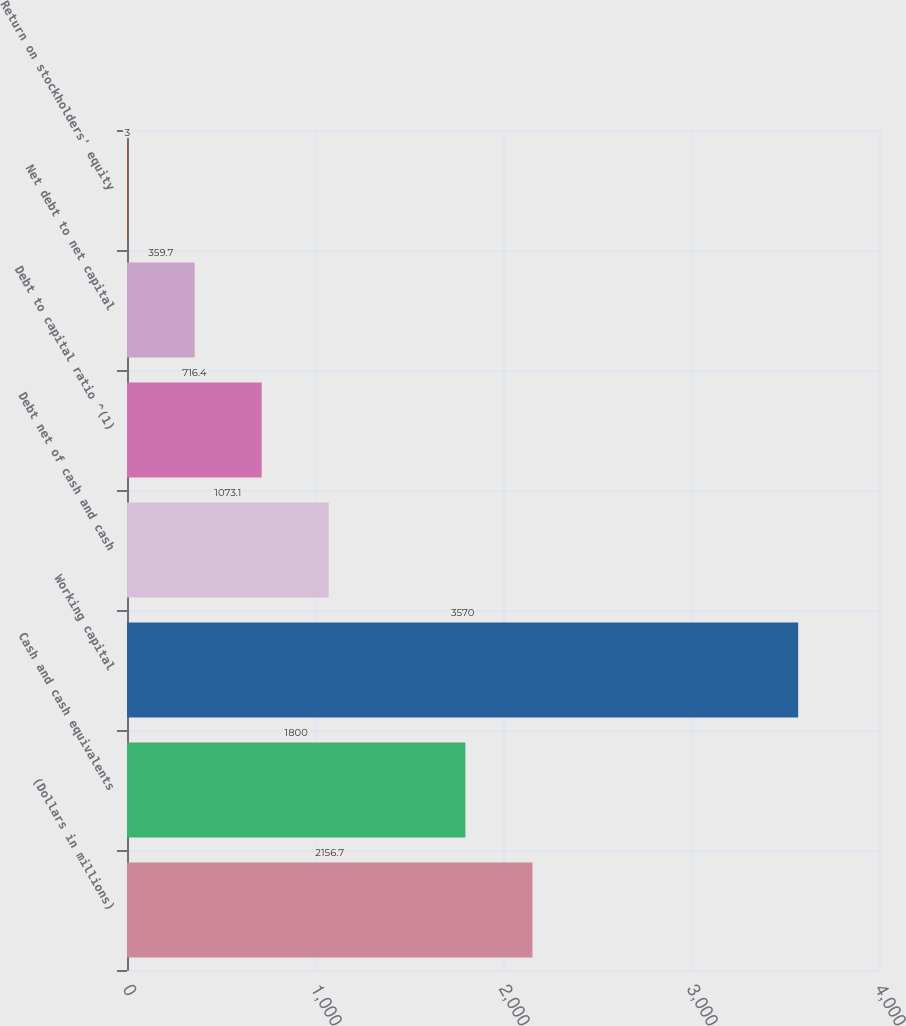Convert chart to OTSL. <chart><loc_0><loc_0><loc_500><loc_500><bar_chart><fcel>(Dollars in millions)<fcel>Cash and cash equivalents<fcel>Working capital<fcel>Debt net of cash and cash<fcel>Debt to capital ratio ^(1)<fcel>Net debt to net capital<fcel>Return on stockholders' equity<nl><fcel>2156.7<fcel>1800<fcel>3570<fcel>1073.1<fcel>716.4<fcel>359.7<fcel>3<nl></chart> 